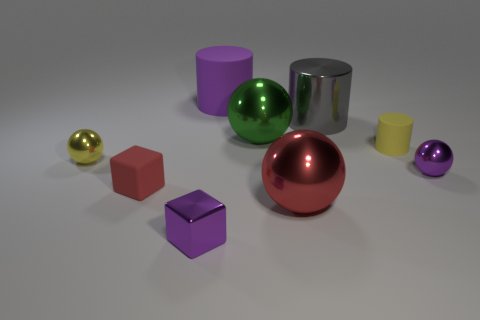How many other things are there of the same shape as the gray object?
Your answer should be very brief. 2. What material is the thing that is the same color as the small matte cube?
Give a very brief answer. Metal. How many big metallic things have the same color as the metallic cube?
Your answer should be compact. 0. The cylinder that is the same material as the large green ball is what color?
Give a very brief answer. Gray. Is there a metallic cylinder that has the same size as the purple block?
Your answer should be very brief. No. Is the number of green balls behind the large gray metal cylinder greater than the number of big gray objects to the left of the big green thing?
Give a very brief answer. No. Is the big sphere in front of the tiny purple ball made of the same material as the ball right of the yellow matte thing?
Keep it short and to the point. Yes. What is the shape of the purple thing that is the same size as the metal cube?
Give a very brief answer. Sphere. Are there any large purple matte things of the same shape as the red matte object?
Your answer should be very brief. No. There is a large thing in front of the yellow rubber cylinder; does it have the same color as the large shiny sphere behind the yellow cylinder?
Make the answer very short. No. 